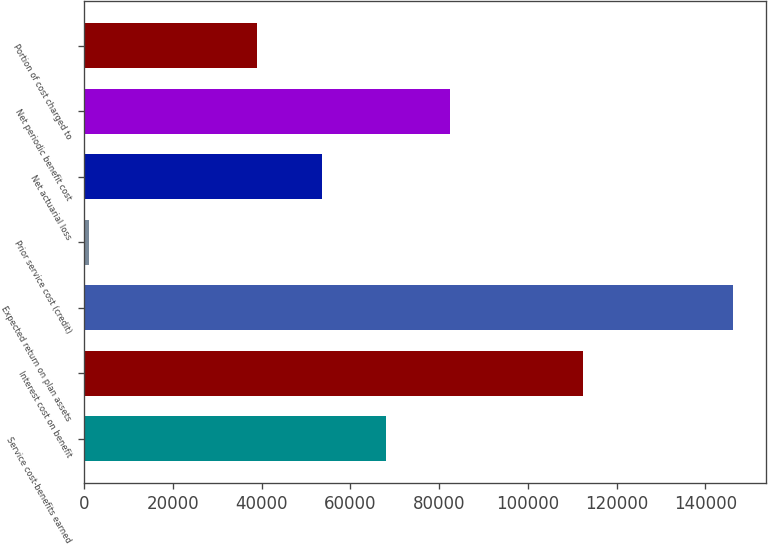Convert chart. <chart><loc_0><loc_0><loc_500><loc_500><bar_chart><fcel>Service cost-benefits earned<fcel>Interest cost on benefit<fcel>Expected return on plan assets<fcel>Prior service cost (credit)<fcel>Net actuarial loss<fcel>Net periodic benefit cost<fcel>Portion of cost charged to<nl><fcel>68015.2<fcel>112392<fcel>146333<fcel>1097<fcel>53491.6<fcel>82538.8<fcel>38968<nl></chart> 